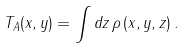Convert formula to latex. <formula><loc_0><loc_0><loc_500><loc_500>T _ { A } ( x , y ) = \int d z \, \rho \left ( x , y , z \right ) .</formula> 